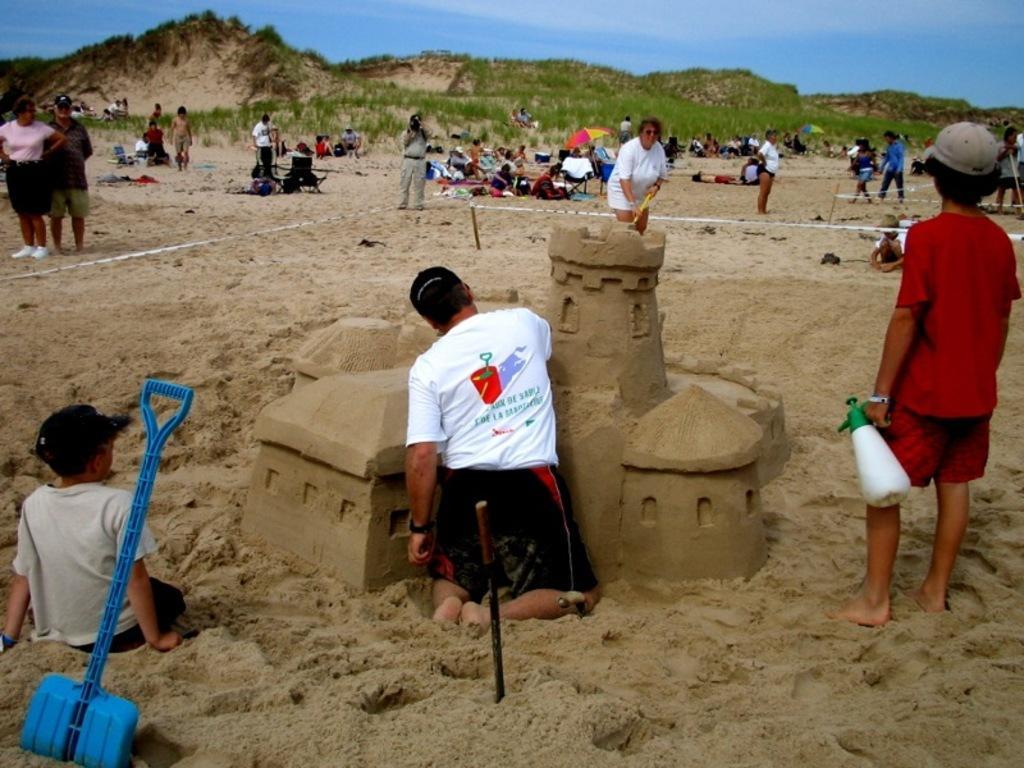Please provide a concise description of this image. This image is taken outdoors. At the top of the image there is the sky with clouds. At the bottom of the image there is sand. In the background there are a few hills. There are a few trees and plants on the ground. Many people are sitting on the ground and a few people are sitting on the resting chairs. A few are standing and a few are walking on the ground. In the middle of the image a boy is sitting on the ground and he is making a sand art. There is a spade and a boy sitting on the ground. On the right side of the image a boy is standing and he is holding a bottle in his hand. 